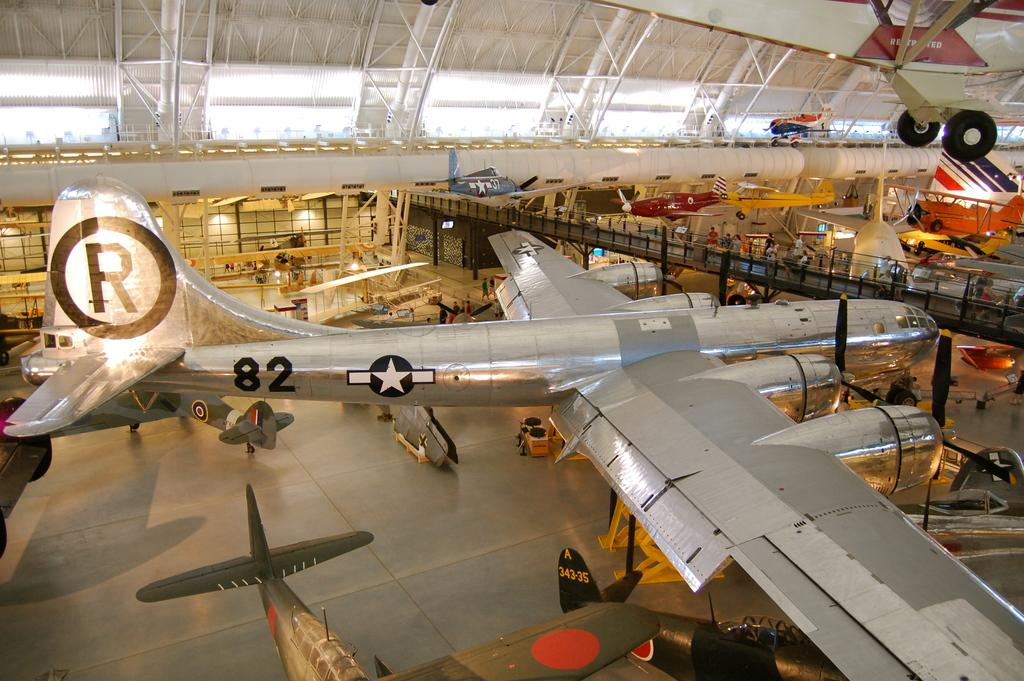<image>
Share a concise interpretation of the image provided. A plane in a large hangar has an R on it's tail and 82 on the side. 